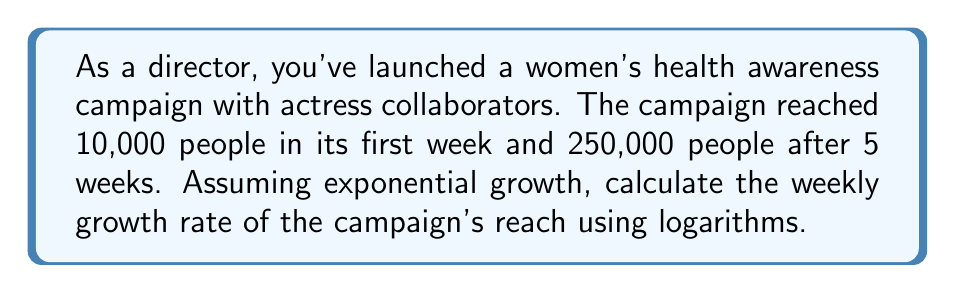Teach me how to tackle this problem. Let's approach this step-by-step using the exponential growth formula and logarithms:

1) The exponential growth formula is:
   $$ A = P(1 + r)^t $$
   Where A is the final amount, P is the initial amount, r is the growth rate, and t is the time period.

2) In this case:
   P = 10,000 (initial reach)
   A = 250,000 (final reach)
   t = 5 (weeks)
   We need to solve for r.

3) Substituting these values:
   $$ 250,000 = 10,000(1 + r)^5 $$

4) Divide both sides by 10,000:
   $$ 25 = (1 + r)^5 $$

5) Take the natural logarithm of both sides:
   $$ \ln(25) = \ln((1 + r)^5) $$

6) Using the logarithm property $\ln(a^b) = b\ln(a)$:
   $$ \ln(25) = 5\ln(1 + r) $$

7) Divide both sides by 5:
   $$ \frac{\ln(25)}{5} = \ln(1 + r) $$

8) Apply the exponential function to both sides:
   $$ e^{\frac{\ln(25)}{5}} = e^{\ln(1 + r)} = 1 + r $$

9) Subtract 1 from both sides:
   $$ e^{\frac{\ln(25)}{5}} - 1 = r $$

10) Calculate the result:
    $$ r \approx 0.2009 \text{ or } 20.09\% $$
Answer: $20.09\%$ 